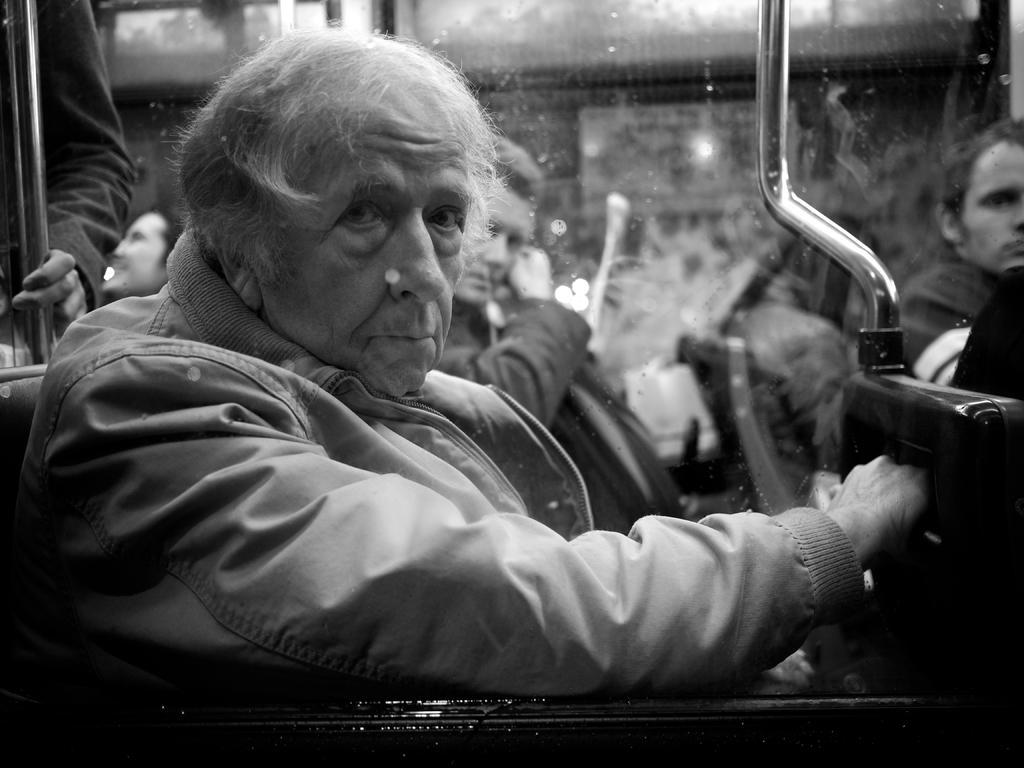Describe this image in one or two sentences. This is a black and white image. Here I can see a person wearing a jacket, sitting and looking at the picture. It seems to be an inside view of a vehicle. In the background there are few people sitting facing towards the right side. Here I can see two metal stands. The background is blurred. 